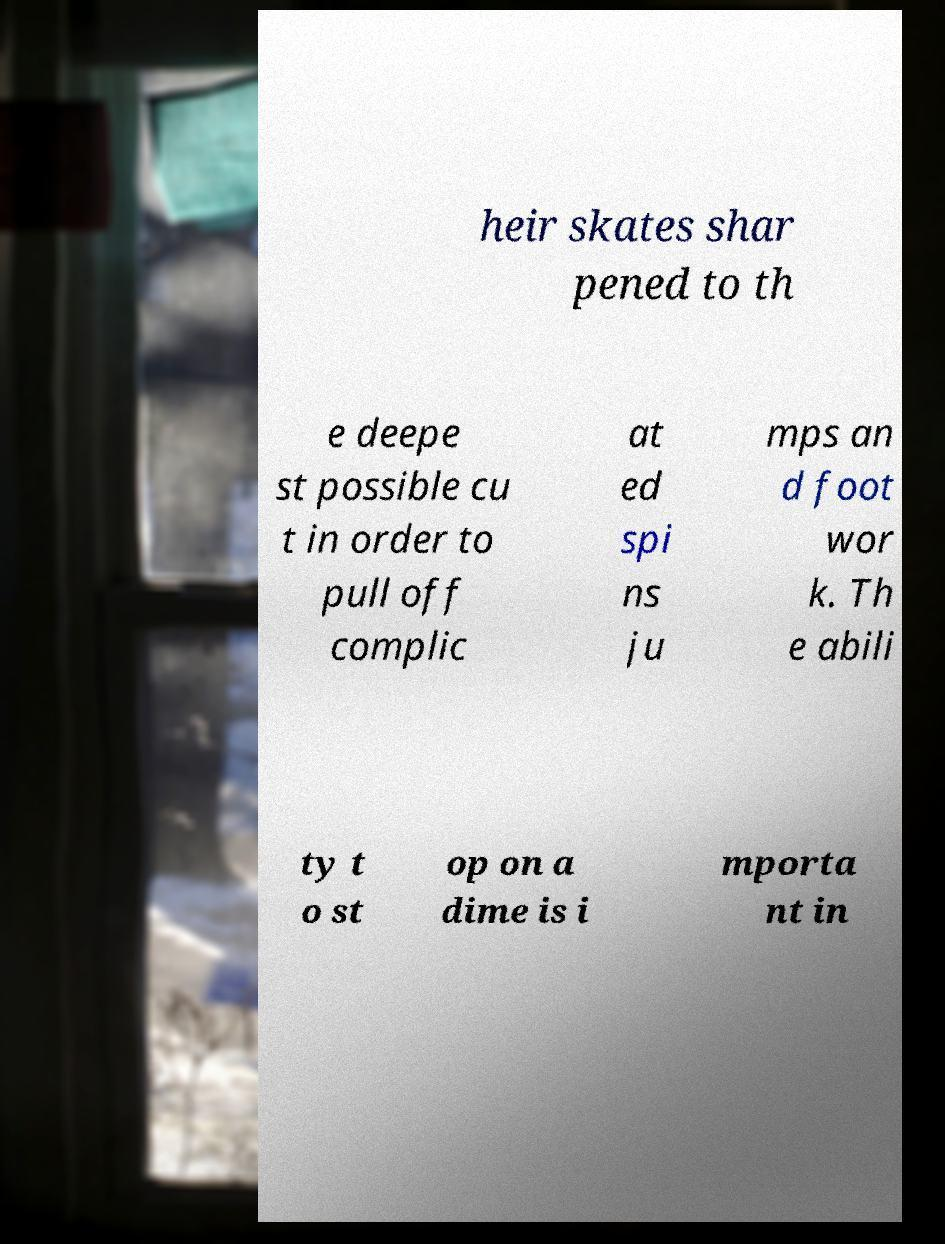Please read and relay the text visible in this image. What does it say? heir skates shar pened to th e deepe st possible cu t in order to pull off complic at ed spi ns ju mps an d foot wor k. Th e abili ty t o st op on a dime is i mporta nt in 